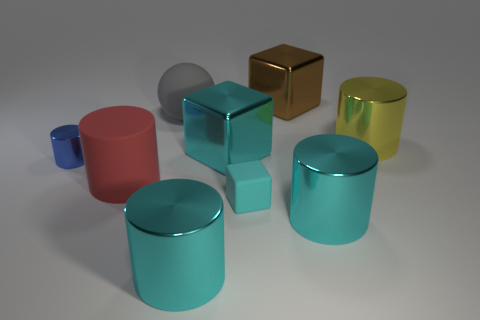What is the size of the shiny cube that is the same color as the tiny matte thing?
Ensure brevity in your answer.  Large. The big matte object left of the gray matte ball that is in front of the brown cube is what shape?
Provide a succinct answer. Cylinder. There is a large cyan shiny thing to the right of the big metal thing that is behind the yellow metallic object; are there any blue cylinders right of it?
Your response must be concise. No. What is the color of the cube that is the same size as the blue metal cylinder?
Give a very brief answer. Cyan. There is a rubber thing that is in front of the big cyan cube and left of the tiny rubber block; what is its shape?
Ensure brevity in your answer.  Cylinder. How big is the metal object that is in front of the cyan object that is to the right of the brown shiny block?
Provide a succinct answer. Large. What number of cylinders have the same color as the small rubber thing?
Provide a short and direct response. 2. What number of other things are the same size as the cyan rubber object?
Your response must be concise. 1. What is the size of the rubber object that is both in front of the large gray rubber ball and right of the large red cylinder?
Give a very brief answer. Small. How many big matte things have the same shape as the tiny blue shiny thing?
Offer a terse response. 1. 